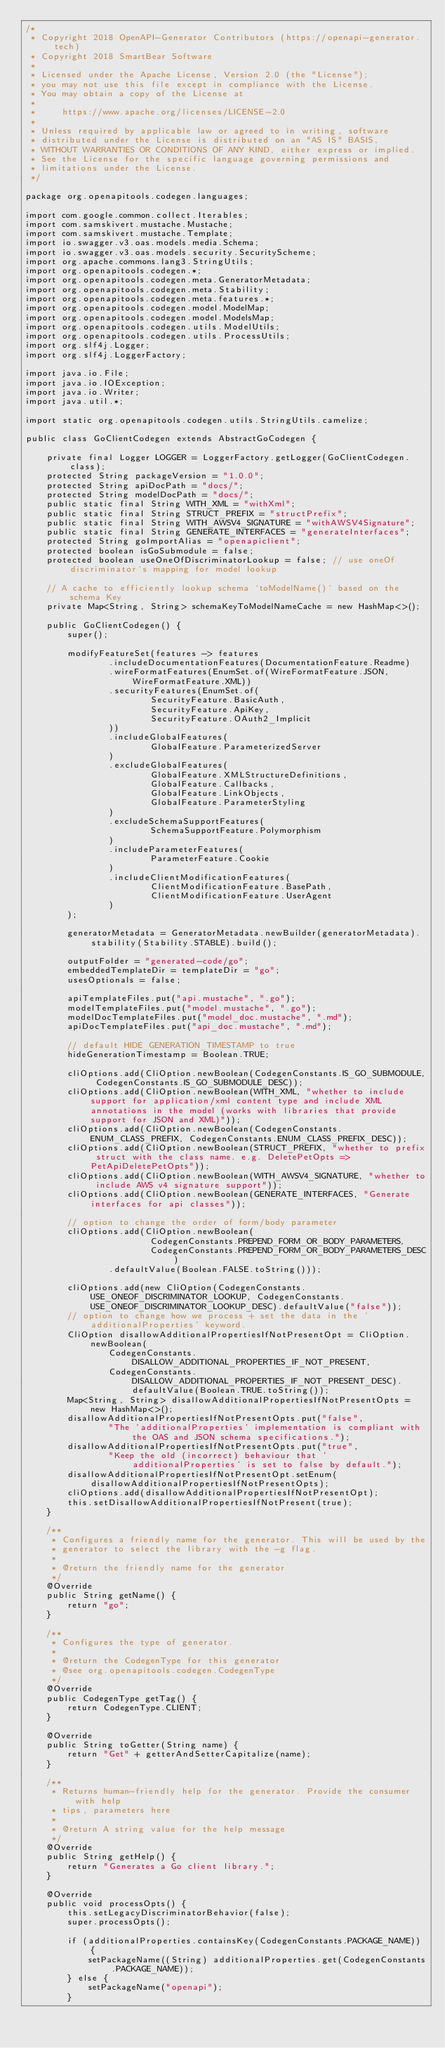<code> <loc_0><loc_0><loc_500><loc_500><_Java_>/*
 * Copyright 2018 OpenAPI-Generator Contributors (https://openapi-generator.tech)
 * Copyright 2018 SmartBear Software
 *
 * Licensed under the Apache License, Version 2.0 (the "License");
 * you may not use this file except in compliance with the License.
 * You may obtain a copy of the License at
 *
 *     https://www.apache.org/licenses/LICENSE-2.0
 *
 * Unless required by applicable law or agreed to in writing, software
 * distributed under the License is distributed on an "AS IS" BASIS,
 * WITHOUT WARRANTIES OR CONDITIONS OF ANY KIND, either express or implied.
 * See the License for the specific language governing permissions and
 * limitations under the License.
 */

package org.openapitools.codegen.languages;

import com.google.common.collect.Iterables;
import com.samskivert.mustache.Mustache;
import com.samskivert.mustache.Template;
import io.swagger.v3.oas.models.media.Schema;
import io.swagger.v3.oas.models.security.SecurityScheme;
import org.apache.commons.lang3.StringUtils;
import org.openapitools.codegen.*;
import org.openapitools.codegen.meta.GeneratorMetadata;
import org.openapitools.codegen.meta.Stability;
import org.openapitools.codegen.meta.features.*;
import org.openapitools.codegen.model.ModelMap;
import org.openapitools.codegen.model.ModelsMap;
import org.openapitools.codegen.utils.ModelUtils;
import org.openapitools.codegen.utils.ProcessUtils;
import org.slf4j.Logger;
import org.slf4j.LoggerFactory;

import java.io.File;
import java.io.IOException;
import java.io.Writer;
import java.util.*;

import static org.openapitools.codegen.utils.StringUtils.camelize;

public class GoClientCodegen extends AbstractGoCodegen {

    private final Logger LOGGER = LoggerFactory.getLogger(GoClientCodegen.class);
    protected String packageVersion = "1.0.0";
    protected String apiDocPath = "docs/";
    protected String modelDocPath = "docs/";
    public static final String WITH_XML = "withXml";
    public static final String STRUCT_PREFIX = "structPrefix";
    public static final String WITH_AWSV4_SIGNATURE = "withAWSV4Signature";
    public static final String GENERATE_INTERFACES = "generateInterfaces";
    protected String goImportAlias = "openapiclient";
    protected boolean isGoSubmodule = false;
    protected boolean useOneOfDiscriminatorLookup = false; // use oneOf discriminator's mapping for model lookup

    // A cache to efficiently lookup schema `toModelName()` based on the schema Key
    private Map<String, String> schemaKeyToModelNameCache = new HashMap<>();

    public GoClientCodegen() {
        super();

        modifyFeatureSet(features -> features
                .includeDocumentationFeatures(DocumentationFeature.Readme)
                .wireFormatFeatures(EnumSet.of(WireFormatFeature.JSON, WireFormatFeature.XML))
                .securityFeatures(EnumSet.of(
                        SecurityFeature.BasicAuth,
                        SecurityFeature.ApiKey,
                        SecurityFeature.OAuth2_Implicit
                ))
                .includeGlobalFeatures(
                        GlobalFeature.ParameterizedServer
                )
                .excludeGlobalFeatures(
                        GlobalFeature.XMLStructureDefinitions,
                        GlobalFeature.Callbacks,
                        GlobalFeature.LinkObjects,
                        GlobalFeature.ParameterStyling
                )
                .excludeSchemaSupportFeatures(
                        SchemaSupportFeature.Polymorphism
                )
                .includeParameterFeatures(
                        ParameterFeature.Cookie
                )
                .includeClientModificationFeatures(
                        ClientModificationFeature.BasePath,
                        ClientModificationFeature.UserAgent
                )
        );

        generatorMetadata = GeneratorMetadata.newBuilder(generatorMetadata).stability(Stability.STABLE).build();

        outputFolder = "generated-code/go";
        embeddedTemplateDir = templateDir = "go";
        usesOptionals = false;

        apiTemplateFiles.put("api.mustache", ".go");
        modelTemplateFiles.put("model.mustache", ".go");
        modelDocTemplateFiles.put("model_doc.mustache", ".md");
        apiDocTemplateFiles.put("api_doc.mustache", ".md");

        // default HIDE_GENERATION_TIMESTAMP to true
        hideGenerationTimestamp = Boolean.TRUE;

        cliOptions.add(CliOption.newBoolean(CodegenConstants.IS_GO_SUBMODULE, CodegenConstants.IS_GO_SUBMODULE_DESC));
        cliOptions.add(CliOption.newBoolean(WITH_XML, "whether to include support for application/xml content type and include XML annotations in the model (works with libraries that provide support for JSON and XML)"));
        cliOptions.add(CliOption.newBoolean(CodegenConstants.ENUM_CLASS_PREFIX, CodegenConstants.ENUM_CLASS_PREFIX_DESC));
        cliOptions.add(CliOption.newBoolean(STRUCT_PREFIX, "whether to prefix struct with the class name. e.g. DeletePetOpts => PetApiDeletePetOpts"));
        cliOptions.add(CliOption.newBoolean(WITH_AWSV4_SIGNATURE, "whether to include AWS v4 signature support"));
        cliOptions.add(CliOption.newBoolean(GENERATE_INTERFACES, "Generate interfaces for api classes"));

        // option to change the order of form/body parameter
        cliOptions.add(CliOption.newBoolean(
                        CodegenConstants.PREPEND_FORM_OR_BODY_PARAMETERS,
                        CodegenConstants.PREPEND_FORM_OR_BODY_PARAMETERS_DESC)
                .defaultValue(Boolean.FALSE.toString()));

        cliOptions.add(new CliOption(CodegenConstants.USE_ONEOF_DISCRIMINATOR_LOOKUP, CodegenConstants.USE_ONEOF_DISCRIMINATOR_LOOKUP_DESC).defaultValue("false"));
        // option to change how we process + set the data in the 'additionalProperties' keyword.
        CliOption disallowAdditionalPropertiesIfNotPresentOpt = CliOption.newBoolean(
                CodegenConstants.DISALLOW_ADDITIONAL_PROPERTIES_IF_NOT_PRESENT,
                CodegenConstants.DISALLOW_ADDITIONAL_PROPERTIES_IF_NOT_PRESENT_DESC).defaultValue(Boolean.TRUE.toString());
        Map<String, String> disallowAdditionalPropertiesIfNotPresentOpts = new HashMap<>();
        disallowAdditionalPropertiesIfNotPresentOpts.put("false",
                "The 'additionalProperties' implementation is compliant with the OAS and JSON schema specifications.");
        disallowAdditionalPropertiesIfNotPresentOpts.put("true",
                "Keep the old (incorrect) behaviour that 'additionalProperties' is set to false by default.");
        disallowAdditionalPropertiesIfNotPresentOpt.setEnum(disallowAdditionalPropertiesIfNotPresentOpts);
        cliOptions.add(disallowAdditionalPropertiesIfNotPresentOpt);
        this.setDisallowAdditionalPropertiesIfNotPresent(true);
    }

    /**
     * Configures a friendly name for the generator. This will be used by the
     * generator to select the library with the -g flag.
     *
     * @return the friendly name for the generator
     */
    @Override
    public String getName() {
        return "go";
    }

    /**
     * Configures the type of generator.
     *
     * @return the CodegenType for this generator
     * @see org.openapitools.codegen.CodegenType
     */
    @Override
    public CodegenType getTag() {
        return CodegenType.CLIENT;
    }

    @Override
    public String toGetter(String name) {
        return "Get" + getterAndSetterCapitalize(name);
    }

    /**
     * Returns human-friendly help for the generator. Provide the consumer with help
     * tips, parameters here
     *
     * @return A string value for the help message
     */
    @Override
    public String getHelp() {
        return "Generates a Go client library.";
    }

    @Override
    public void processOpts() {
        this.setLegacyDiscriminatorBehavior(false);
        super.processOpts();

        if (additionalProperties.containsKey(CodegenConstants.PACKAGE_NAME)) {
            setPackageName((String) additionalProperties.get(CodegenConstants.PACKAGE_NAME));
        } else {
            setPackageName("openapi");
        }
</code> 